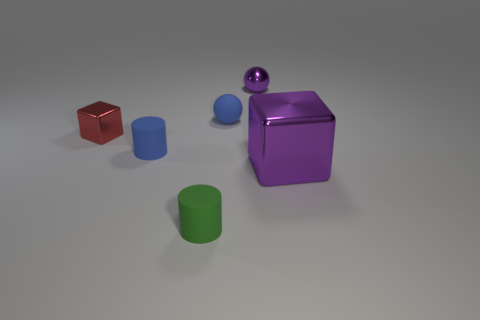Add 1 big purple cubes. How many objects exist? 7 Subtract all cubes. How many objects are left? 4 Add 4 tiny green cylinders. How many tiny green cylinders are left? 5 Add 1 yellow metallic cylinders. How many yellow metallic cylinders exist? 1 Subtract 1 purple balls. How many objects are left? 5 Subtract all tiny brown metallic things. Subtract all green matte cylinders. How many objects are left? 5 